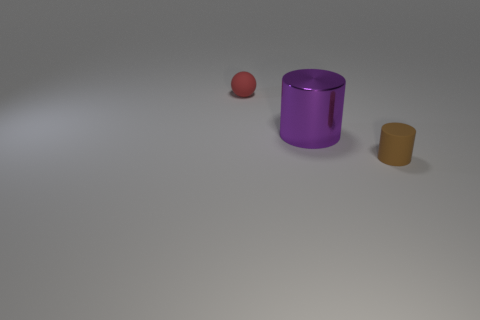Are the red thing and the large purple cylinder made of the same material?
Provide a succinct answer. No. How many large purple objects are to the right of the large object?
Offer a terse response. 0. What is the size of the matte thing that is the same shape as the big purple metallic object?
Make the answer very short. Small. How many gray things are things or rubber balls?
Ensure brevity in your answer.  0. What number of red objects are in front of the tiny object that is behind the tiny brown matte thing?
Ensure brevity in your answer.  0. What number of other objects are the same shape as the small brown object?
Your answer should be compact. 1. What number of small balls have the same color as the big metallic thing?
Your response must be concise. 0. What is the color of the tiny object that is the same material as the sphere?
Keep it short and to the point. Brown. Are there any rubber spheres of the same size as the red thing?
Give a very brief answer. No. Are there more metal objects left of the metallic object than things that are left of the small brown thing?
Provide a short and direct response. No. 